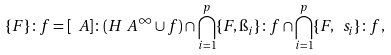Convert formula to latex. <formula><loc_0><loc_0><loc_500><loc_500>\{ F \} \colon f = [ \ A ] \colon ( H _ { \ } A ^ { \infty } \cup f ) \cap \bigcap _ { i = 1 } ^ { p } \{ F , \i _ { i } \} \colon f \cap \bigcap _ { i = 1 } ^ { p } \{ F , \ s _ { i } \} \colon f ,</formula> 